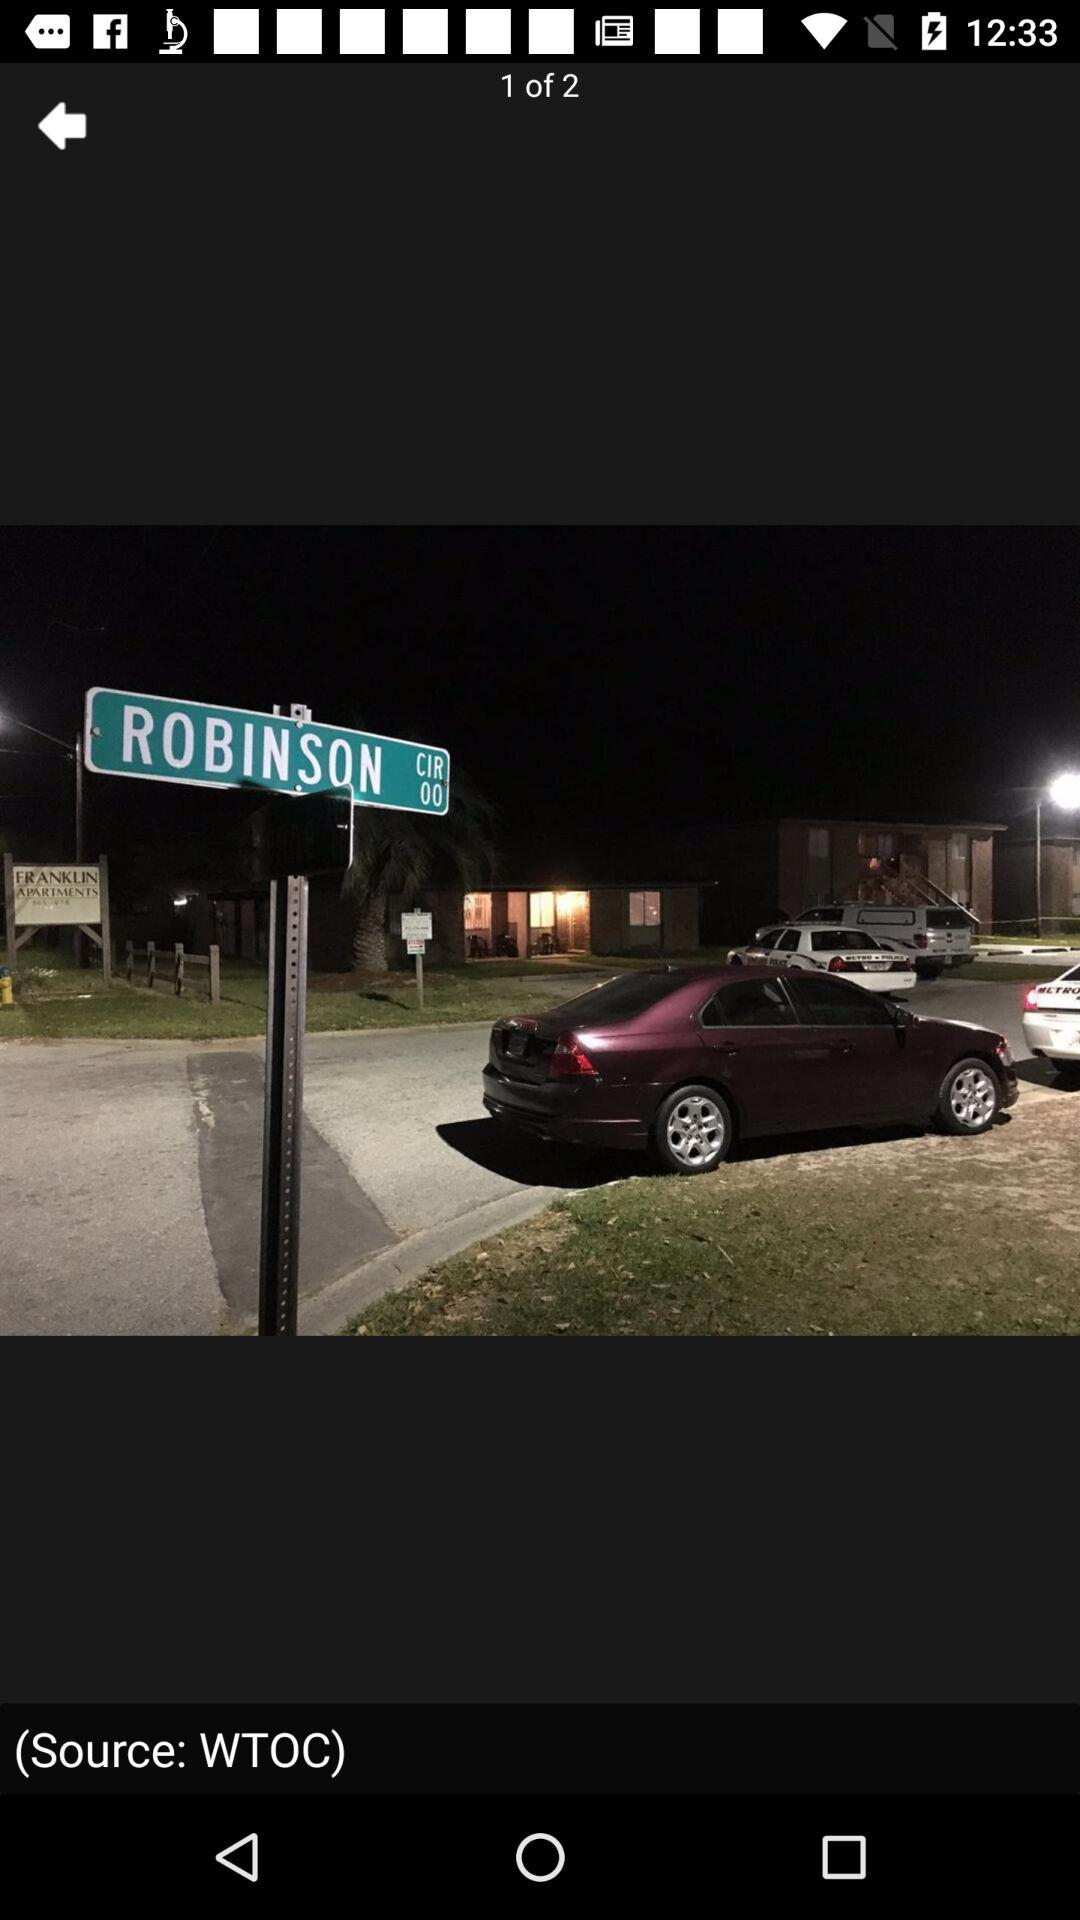Which image is the person currently on? The person is currently on the first image. 